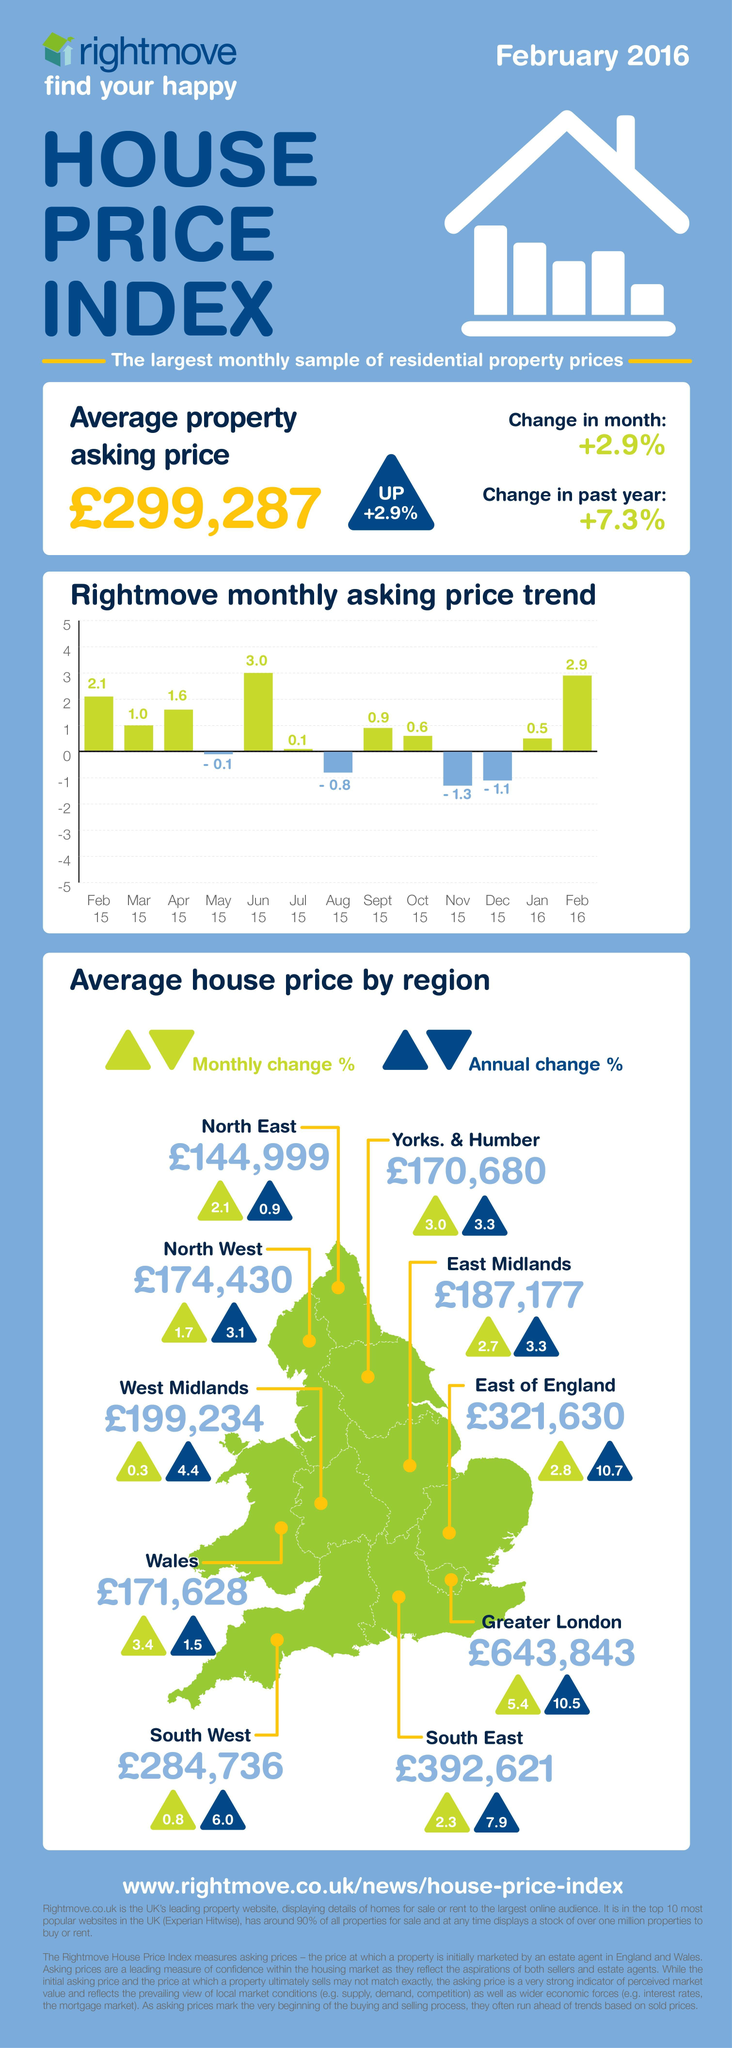Which region in UK has the highest annual change percentage of the average house price?
Answer the question with a short phrase. East of England What is the average house price in East Midlands as of February 2016? £187,177 Which region in UK has the highest monthly change percentage of the average house price? Greater London What is the monthly change percentage of the average house price in North east of UK? 2.1 What is the annual change percentage of the average house price in Greater London? 10.5 What is the average house price in West Midlands as of February 2016? ₹199,234 Which region in UK has recorded the highest average house price as of February 2016? Greater London What is the annual change percentage of the average house price in Wales? 1.5 Which region in UK has the lowest annual change percentage of the average house price? North East 